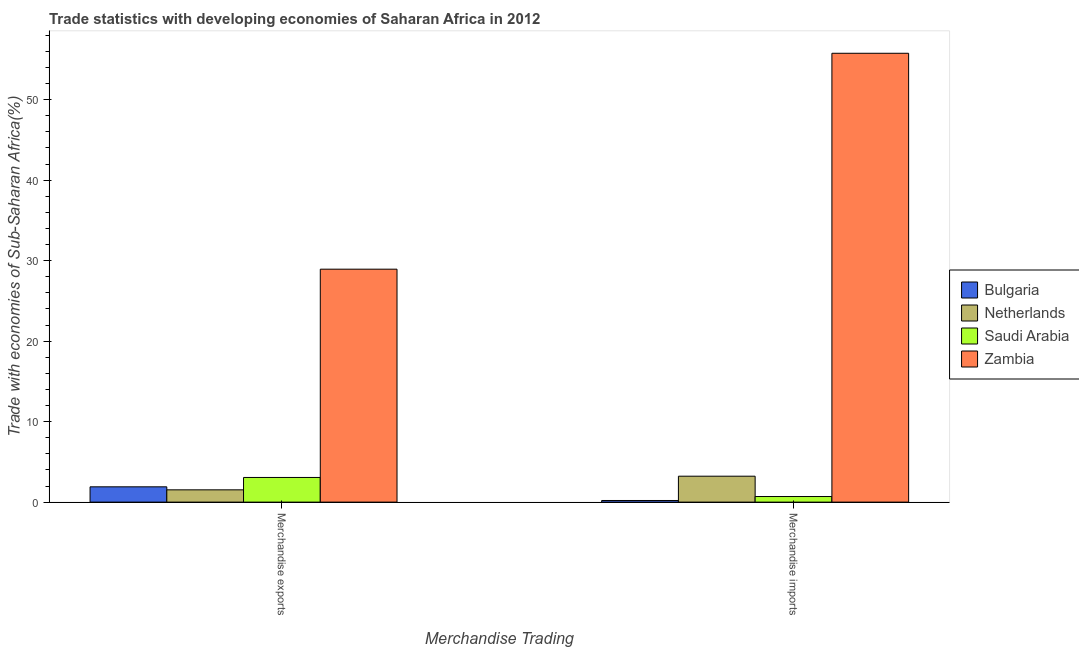How many different coloured bars are there?
Make the answer very short. 4. How many bars are there on the 1st tick from the left?
Provide a succinct answer. 4. What is the merchandise imports in Netherlands?
Offer a terse response. 3.22. Across all countries, what is the maximum merchandise exports?
Offer a very short reply. 28.94. Across all countries, what is the minimum merchandise imports?
Provide a short and direct response. 0.2. In which country was the merchandise exports maximum?
Provide a short and direct response. Zambia. What is the total merchandise exports in the graph?
Provide a short and direct response. 35.43. What is the difference between the merchandise imports in Netherlands and that in Zambia?
Your answer should be very brief. -52.54. What is the difference between the merchandise exports in Netherlands and the merchandise imports in Zambia?
Your answer should be very brief. -54.24. What is the average merchandise imports per country?
Your answer should be very brief. 14.97. What is the difference between the merchandise imports and merchandise exports in Zambia?
Ensure brevity in your answer.  26.82. What is the ratio of the merchandise imports in Saudi Arabia to that in Bulgaria?
Offer a very short reply. 3.42. Is the merchandise exports in Netherlands less than that in Zambia?
Your answer should be very brief. Yes. In how many countries, is the merchandise imports greater than the average merchandise imports taken over all countries?
Your answer should be compact. 1. What does the 1st bar from the left in Merchandise imports represents?
Give a very brief answer. Bulgaria. What does the 3rd bar from the right in Merchandise exports represents?
Keep it short and to the point. Netherlands. How many bars are there?
Your response must be concise. 8. Are all the bars in the graph horizontal?
Keep it short and to the point. No. How many countries are there in the graph?
Offer a terse response. 4. What is the difference between two consecutive major ticks on the Y-axis?
Provide a succinct answer. 10. Does the graph contain grids?
Offer a terse response. No. How many legend labels are there?
Your answer should be compact. 4. How are the legend labels stacked?
Keep it short and to the point. Vertical. What is the title of the graph?
Your answer should be compact. Trade statistics with developing economies of Saharan Africa in 2012. Does "Small states" appear as one of the legend labels in the graph?
Offer a terse response. No. What is the label or title of the X-axis?
Ensure brevity in your answer.  Merchandise Trading. What is the label or title of the Y-axis?
Keep it short and to the point. Trade with economies of Sub-Saharan Africa(%). What is the Trade with economies of Sub-Saharan Africa(%) in Bulgaria in Merchandise exports?
Ensure brevity in your answer.  1.9. What is the Trade with economies of Sub-Saharan Africa(%) in Netherlands in Merchandise exports?
Provide a succinct answer. 1.53. What is the Trade with economies of Sub-Saharan Africa(%) in Saudi Arabia in Merchandise exports?
Ensure brevity in your answer.  3.06. What is the Trade with economies of Sub-Saharan Africa(%) of Zambia in Merchandise exports?
Your response must be concise. 28.94. What is the Trade with economies of Sub-Saharan Africa(%) in Bulgaria in Merchandise imports?
Offer a terse response. 0.2. What is the Trade with economies of Sub-Saharan Africa(%) in Netherlands in Merchandise imports?
Your answer should be compact. 3.22. What is the Trade with economies of Sub-Saharan Africa(%) in Saudi Arabia in Merchandise imports?
Your response must be concise. 0.7. What is the Trade with economies of Sub-Saharan Africa(%) in Zambia in Merchandise imports?
Give a very brief answer. 55.76. Across all Merchandise Trading, what is the maximum Trade with economies of Sub-Saharan Africa(%) in Bulgaria?
Make the answer very short. 1.9. Across all Merchandise Trading, what is the maximum Trade with economies of Sub-Saharan Africa(%) of Netherlands?
Your response must be concise. 3.22. Across all Merchandise Trading, what is the maximum Trade with economies of Sub-Saharan Africa(%) of Saudi Arabia?
Provide a succinct answer. 3.06. Across all Merchandise Trading, what is the maximum Trade with economies of Sub-Saharan Africa(%) in Zambia?
Your answer should be compact. 55.76. Across all Merchandise Trading, what is the minimum Trade with economies of Sub-Saharan Africa(%) of Bulgaria?
Provide a short and direct response. 0.2. Across all Merchandise Trading, what is the minimum Trade with economies of Sub-Saharan Africa(%) in Netherlands?
Your response must be concise. 1.53. Across all Merchandise Trading, what is the minimum Trade with economies of Sub-Saharan Africa(%) in Saudi Arabia?
Your answer should be very brief. 0.7. Across all Merchandise Trading, what is the minimum Trade with economies of Sub-Saharan Africa(%) of Zambia?
Provide a short and direct response. 28.94. What is the total Trade with economies of Sub-Saharan Africa(%) in Bulgaria in the graph?
Ensure brevity in your answer.  2.1. What is the total Trade with economies of Sub-Saharan Africa(%) in Netherlands in the graph?
Your answer should be very brief. 4.75. What is the total Trade with economies of Sub-Saharan Africa(%) in Saudi Arabia in the graph?
Ensure brevity in your answer.  3.76. What is the total Trade with economies of Sub-Saharan Africa(%) in Zambia in the graph?
Keep it short and to the point. 84.7. What is the difference between the Trade with economies of Sub-Saharan Africa(%) of Bulgaria in Merchandise exports and that in Merchandise imports?
Offer a terse response. 1.7. What is the difference between the Trade with economies of Sub-Saharan Africa(%) of Netherlands in Merchandise exports and that in Merchandise imports?
Provide a short and direct response. -1.7. What is the difference between the Trade with economies of Sub-Saharan Africa(%) of Saudi Arabia in Merchandise exports and that in Merchandise imports?
Provide a short and direct response. 2.37. What is the difference between the Trade with economies of Sub-Saharan Africa(%) of Zambia in Merchandise exports and that in Merchandise imports?
Keep it short and to the point. -26.82. What is the difference between the Trade with economies of Sub-Saharan Africa(%) in Bulgaria in Merchandise exports and the Trade with economies of Sub-Saharan Africa(%) in Netherlands in Merchandise imports?
Your answer should be very brief. -1.32. What is the difference between the Trade with economies of Sub-Saharan Africa(%) in Bulgaria in Merchandise exports and the Trade with economies of Sub-Saharan Africa(%) in Saudi Arabia in Merchandise imports?
Make the answer very short. 1.21. What is the difference between the Trade with economies of Sub-Saharan Africa(%) in Bulgaria in Merchandise exports and the Trade with economies of Sub-Saharan Africa(%) in Zambia in Merchandise imports?
Provide a short and direct response. -53.86. What is the difference between the Trade with economies of Sub-Saharan Africa(%) of Netherlands in Merchandise exports and the Trade with economies of Sub-Saharan Africa(%) of Saudi Arabia in Merchandise imports?
Offer a very short reply. 0.83. What is the difference between the Trade with economies of Sub-Saharan Africa(%) of Netherlands in Merchandise exports and the Trade with economies of Sub-Saharan Africa(%) of Zambia in Merchandise imports?
Your answer should be compact. -54.24. What is the difference between the Trade with economies of Sub-Saharan Africa(%) in Saudi Arabia in Merchandise exports and the Trade with economies of Sub-Saharan Africa(%) in Zambia in Merchandise imports?
Provide a short and direct response. -52.7. What is the average Trade with economies of Sub-Saharan Africa(%) in Bulgaria per Merchandise Trading?
Provide a succinct answer. 1.05. What is the average Trade with economies of Sub-Saharan Africa(%) in Netherlands per Merchandise Trading?
Give a very brief answer. 2.37. What is the average Trade with economies of Sub-Saharan Africa(%) of Saudi Arabia per Merchandise Trading?
Your response must be concise. 1.88. What is the average Trade with economies of Sub-Saharan Africa(%) in Zambia per Merchandise Trading?
Your answer should be very brief. 42.35. What is the difference between the Trade with economies of Sub-Saharan Africa(%) of Bulgaria and Trade with economies of Sub-Saharan Africa(%) of Netherlands in Merchandise exports?
Offer a very short reply. 0.37. What is the difference between the Trade with economies of Sub-Saharan Africa(%) of Bulgaria and Trade with economies of Sub-Saharan Africa(%) of Saudi Arabia in Merchandise exports?
Ensure brevity in your answer.  -1.16. What is the difference between the Trade with economies of Sub-Saharan Africa(%) of Bulgaria and Trade with economies of Sub-Saharan Africa(%) of Zambia in Merchandise exports?
Offer a very short reply. -27.04. What is the difference between the Trade with economies of Sub-Saharan Africa(%) of Netherlands and Trade with economies of Sub-Saharan Africa(%) of Saudi Arabia in Merchandise exports?
Provide a succinct answer. -1.54. What is the difference between the Trade with economies of Sub-Saharan Africa(%) of Netherlands and Trade with economies of Sub-Saharan Africa(%) of Zambia in Merchandise exports?
Your answer should be compact. -27.41. What is the difference between the Trade with economies of Sub-Saharan Africa(%) in Saudi Arabia and Trade with economies of Sub-Saharan Africa(%) in Zambia in Merchandise exports?
Your answer should be compact. -25.87. What is the difference between the Trade with economies of Sub-Saharan Africa(%) in Bulgaria and Trade with economies of Sub-Saharan Africa(%) in Netherlands in Merchandise imports?
Provide a succinct answer. -3.02. What is the difference between the Trade with economies of Sub-Saharan Africa(%) in Bulgaria and Trade with economies of Sub-Saharan Africa(%) in Saudi Arabia in Merchandise imports?
Your answer should be compact. -0.49. What is the difference between the Trade with economies of Sub-Saharan Africa(%) of Bulgaria and Trade with economies of Sub-Saharan Africa(%) of Zambia in Merchandise imports?
Ensure brevity in your answer.  -55.56. What is the difference between the Trade with economies of Sub-Saharan Africa(%) of Netherlands and Trade with economies of Sub-Saharan Africa(%) of Saudi Arabia in Merchandise imports?
Make the answer very short. 2.53. What is the difference between the Trade with economies of Sub-Saharan Africa(%) of Netherlands and Trade with economies of Sub-Saharan Africa(%) of Zambia in Merchandise imports?
Provide a short and direct response. -52.54. What is the difference between the Trade with economies of Sub-Saharan Africa(%) in Saudi Arabia and Trade with economies of Sub-Saharan Africa(%) in Zambia in Merchandise imports?
Offer a terse response. -55.07. What is the ratio of the Trade with economies of Sub-Saharan Africa(%) of Bulgaria in Merchandise exports to that in Merchandise imports?
Provide a succinct answer. 9.35. What is the ratio of the Trade with economies of Sub-Saharan Africa(%) of Netherlands in Merchandise exports to that in Merchandise imports?
Your response must be concise. 0.47. What is the ratio of the Trade with economies of Sub-Saharan Africa(%) in Saudi Arabia in Merchandise exports to that in Merchandise imports?
Provide a succinct answer. 4.41. What is the ratio of the Trade with economies of Sub-Saharan Africa(%) in Zambia in Merchandise exports to that in Merchandise imports?
Keep it short and to the point. 0.52. What is the difference between the highest and the second highest Trade with economies of Sub-Saharan Africa(%) of Bulgaria?
Give a very brief answer. 1.7. What is the difference between the highest and the second highest Trade with economies of Sub-Saharan Africa(%) in Netherlands?
Offer a very short reply. 1.7. What is the difference between the highest and the second highest Trade with economies of Sub-Saharan Africa(%) in Saudi Arabia?
Provide a succinct answer. 2.37. What is the difference between the highest and the second highest Trade with economies of Sub-Saharan Africa(%) of Zambia?
Ensure brevity in your answer.  26.82. What is the difference between the highest and the lowest Trade with economies of Sub-Saharan Africa(%) in Bulgaria?
Keep it short and to the point. 1.7. What is the difference between the highest and the lowest Trade with economies of Sub-Saharan Africa(%) of Netherlands?
Your answer should be compact. 1.7. What is the difference between the highest and the lowest Trade with economies of Sub-Saharan Africa(%) in Saudi Arabia?
Offer a very short reply. 2.37. What is the difference between the highest and the lowest Trade with economies of Sub-Saharan Africa(%) in Zambia?
Ensure brevity in your answer.  26.82. 